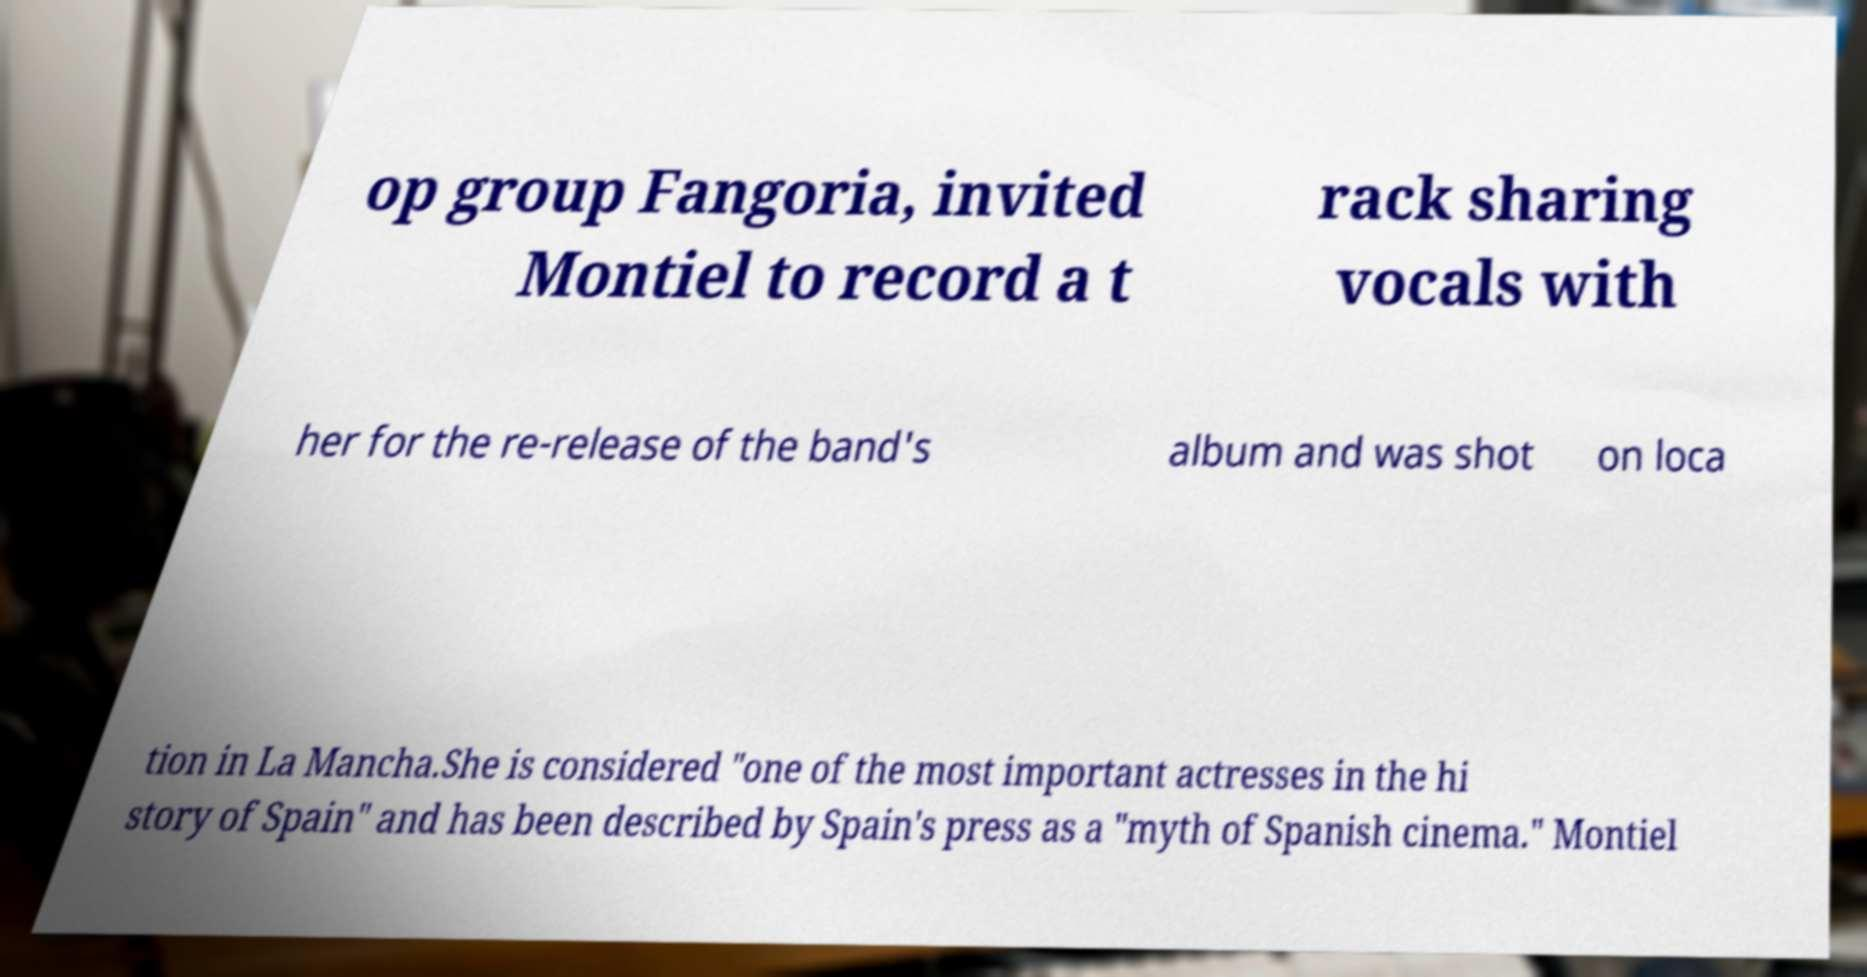There's text embedded in this image that I need extracted. Can you transcribe it verbatim? op group Fangoria, invited Montiel to record a t rack sharing vocals with her for the re-release of the band's album and was shot on loca tion in La Mancha.She is considered "one of the most important actresses in the hi story of Spain" and has been described by Spain's press as a "myth of Spanish cinema." Montiel 